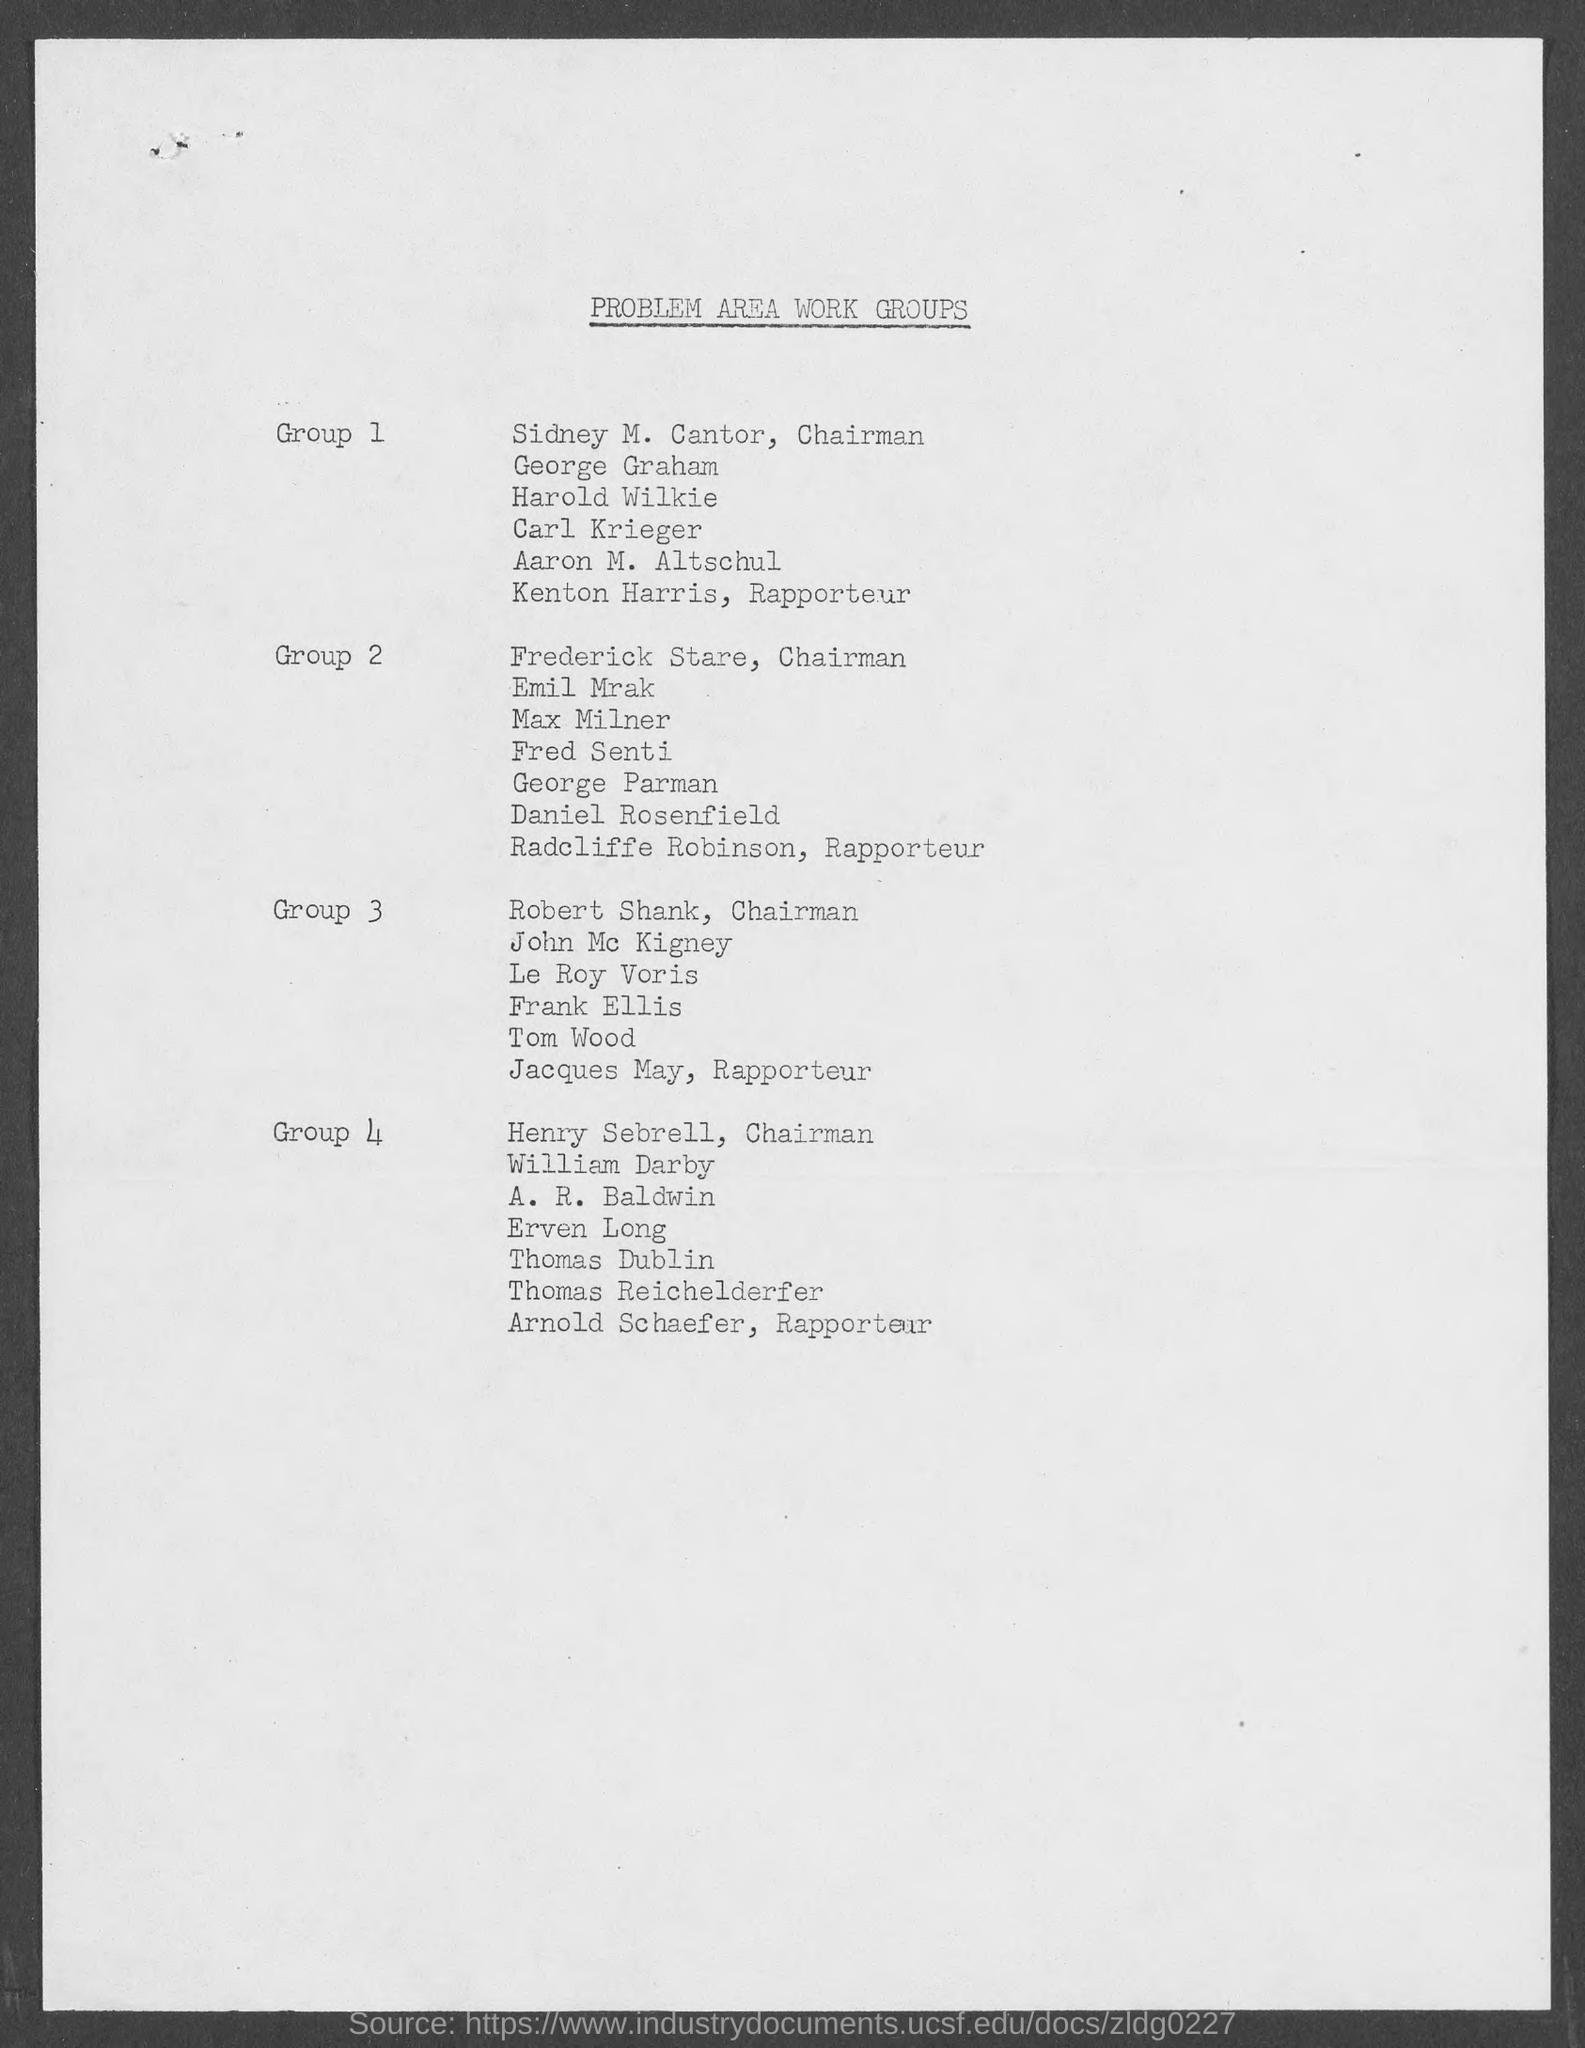What is the document title?
Ensure brevity in your answer.  Problem area work groups. Who is the chairman of Group 1?
Your answer should be very brief. Sidney M. Cantor. Who is the Rapporteur of Group 2?
Your answer should be very brief. Radcliffe Robinson. To which group does Henry Sebrell belong to?
Ensure brevity in your answer.  Group 4. 